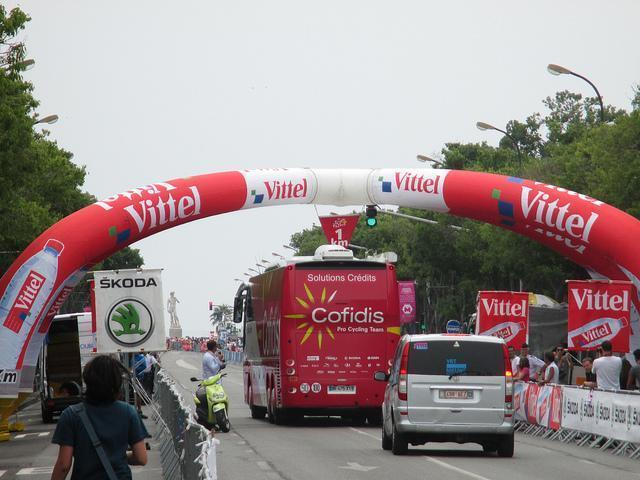How many cars are behind the bus?
Give a very brief answer. 1. 